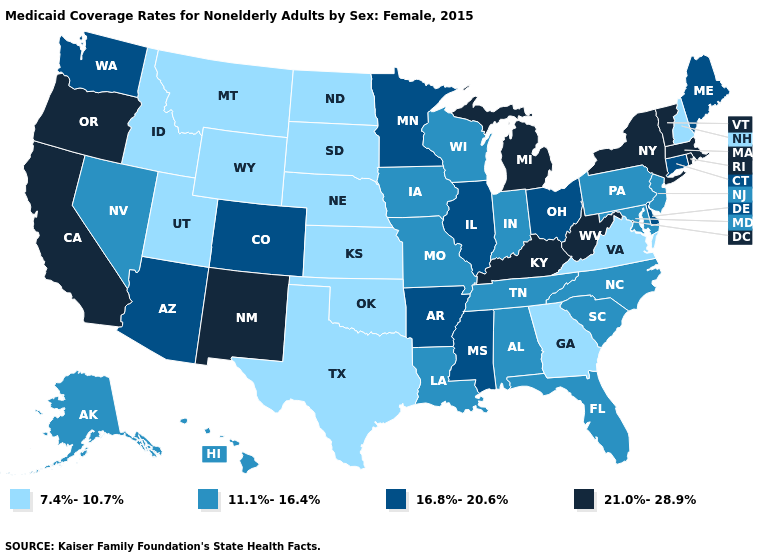What is the value of New York?
Quick response, please. 21.0%-28.9%. Which states have the highest value in the USA?
Keep it brief. California, Kentucky, Massachusetts, Michigan, New Mexico, New York, Oregon, Rhode Island, Vermont, West Virginia. What is the value of Rhode Island?
Short answer required. 21.0%-28.9%. What is the value of New Mexico?
Write a very short answer. 21.0%-28.9%. What is the value of Massachusetts?
Quick response, please. 21.0%-28.9%. Does the first symbol in the legend represent the smallest category?
Quick response, please. Yes. What is the value of Louisiana?
Write a very short answer. 11.1%-16.4%. Does Washington have the highest value in the West?
Give a very brief answer. No. Does Montana have the lowest value in the USA?
Short answer required. Yes. Does Wisconsin have the lowest value in the USA?
Short answer required. No. Name the states that have a value in the range 7.4%-10.7%?
Be succinct. Georgia, Idaho, Kansas, Montana, Nebraska, New Hampshire, North Dakota, Oklahoma, South Dakota, Texas, Utah, Virginia, Wyoming. Does the first symbol in the legend represent the smallest category?
Give a very brief answer. Yes. Does the first symbol in the legend represent the smallest category?
Quick response, please. Yes. What is the lowest value in the USA?
Answer briefly. 7.4%-10.7%. Name the states that have a value in the range 21.0%-28.9%?
Quick response, please. California, Kentucky, Massachusetts, Michigan, New Mexico, New York, Oregon, Rhode Island, Vermont, West Virginia. 